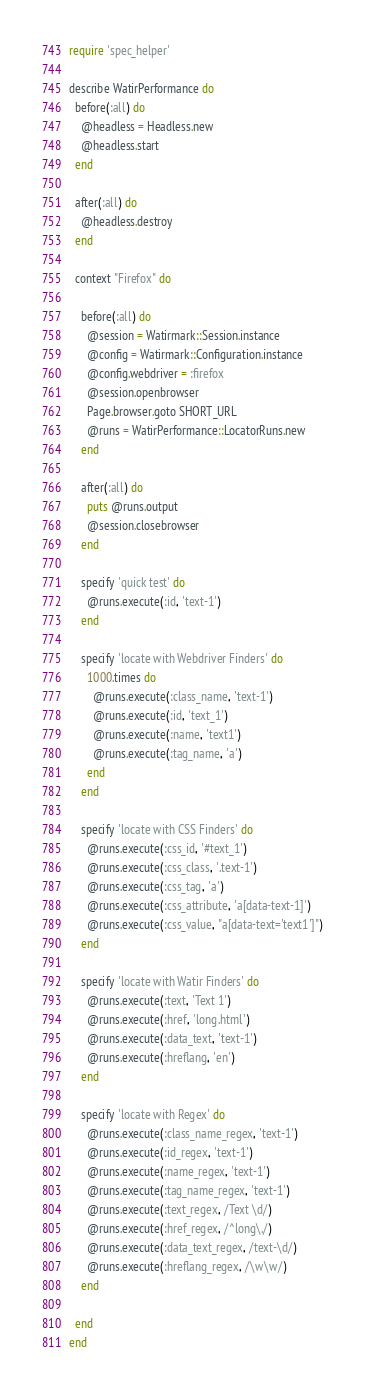<code> <loc_0><loc_0><loc_500><loc_500><_Ruby_>require 'spec_helper'

describe WatirPerformance do
  before(:all) do
    @headless = Headless.new
    @headless.start
  end

  after(:all) do
    @headless.destroy
  end

  context "Firefox" do

    before(:all) do
      @session = Watirmark::Session.instance
      @config = Watirmark::Configuration.instance
      @config.webdriver = :firefox
      @session.openbrowser
      Page.browser.goto SHORT_URL
      @runs = WatirPerformance::LocatorRuns.new
    end

    after(:all) do
      puts @runs.output
      @session.closebrowser
    end

    specify 'quick test' do
      @runs.execute(:id, 'text-1')
    end

    specify 'locate with Webdriver Finders' do
      1000.times do
        @runs.execute(:class_name, 'text-1')
        @runs.execute(:id, 'text_1')
        @runs.execute(:name, 'text1')
        @runs.execute(:tag_name, 'a')
      end
    end

    specify 'locate with CSS Finders' do
      @runs.execute(:css_id, '#text_1')
      @runs.execute(:css_class, '.text-1')
      @runs.execute(:css_tag, 'a')
      @runs.execute(:css_attribute, 'a[data-text-1]')
      @runs.execute(:css_value, "a[data-text='text1']")
    end

    specify 'locate with Watir Finders' do
      @runs.execute(:text, 'Text 1')
      @runs.execute(:href, 'long.html')
      @runs.execute(:data_text, 'text-1')
      @runs.execute(:hreflang, 'en')
    end

    specify 'locate with Regex' do
      @runs.execute(:class_name_regex, 'text-1')
      @runs.execute(:id_regex, 'text-1')
      @runs.execute(:name_regex, 'text-1')
      @runs.execute(:tag_name_regex, 'text-1')
      @runs.execute(:text_regex, /Text \d/)
      @runs.execute(:href_regex, /^long\./)
      @runs.execute(:data_text_regex, /text-\d/)
      @runs.execute(:hreflang_regex, /\w\w/)
    end

  end
end
</code> 